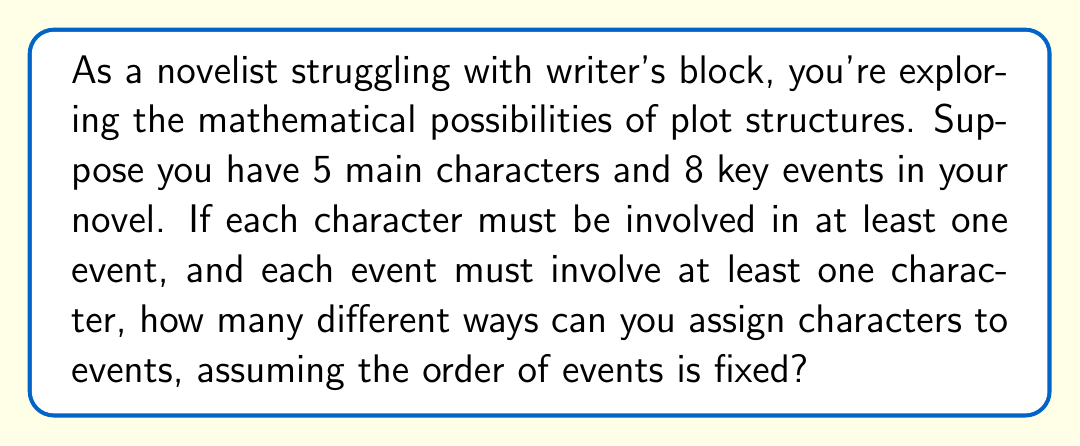Could you help me with this problem? Let's approach this step-by-step:

1) We have 5 characters and 8 events. For each event, we need to decide which characters are involved.

2) For each event, we have two choices for each character: they are either involved or not involved.

3) This means for each event, we have $2^5 = 32$ possible combinations of characters.

4) However, we can't have an event with no characters involved. So we need to subtract 1 (the case where no character is involved) from each event's possibilities.

5) Thus, for each event, we have $2^5 - 1 = 31$ valid combinations.

6) Since there are 8 events, and the order is fixed, we multiply these possibilities:

   $$(2^5 - 1)^8 = 31^8$$

7) However, we also need to ensure that each character is involved in at least one event. The probability of this happening naturally in our current count is very high, but not guaranteed.

8) To be absolutely certain, we would need to subtract all the cases where one or more characters are not involved in any event. This would involve using the principle of inclusion-exclusion, which is quite complex for this scenario.

9) For the sake of this problem, we'll assume that the requirement of each character being involved in at least one event is naturally met in the vast majority of cases, and use our calculated number as a close approximation.

Therefore, the number of possible plot structures is approximately $31^8$.
Answer: $31^8$ 